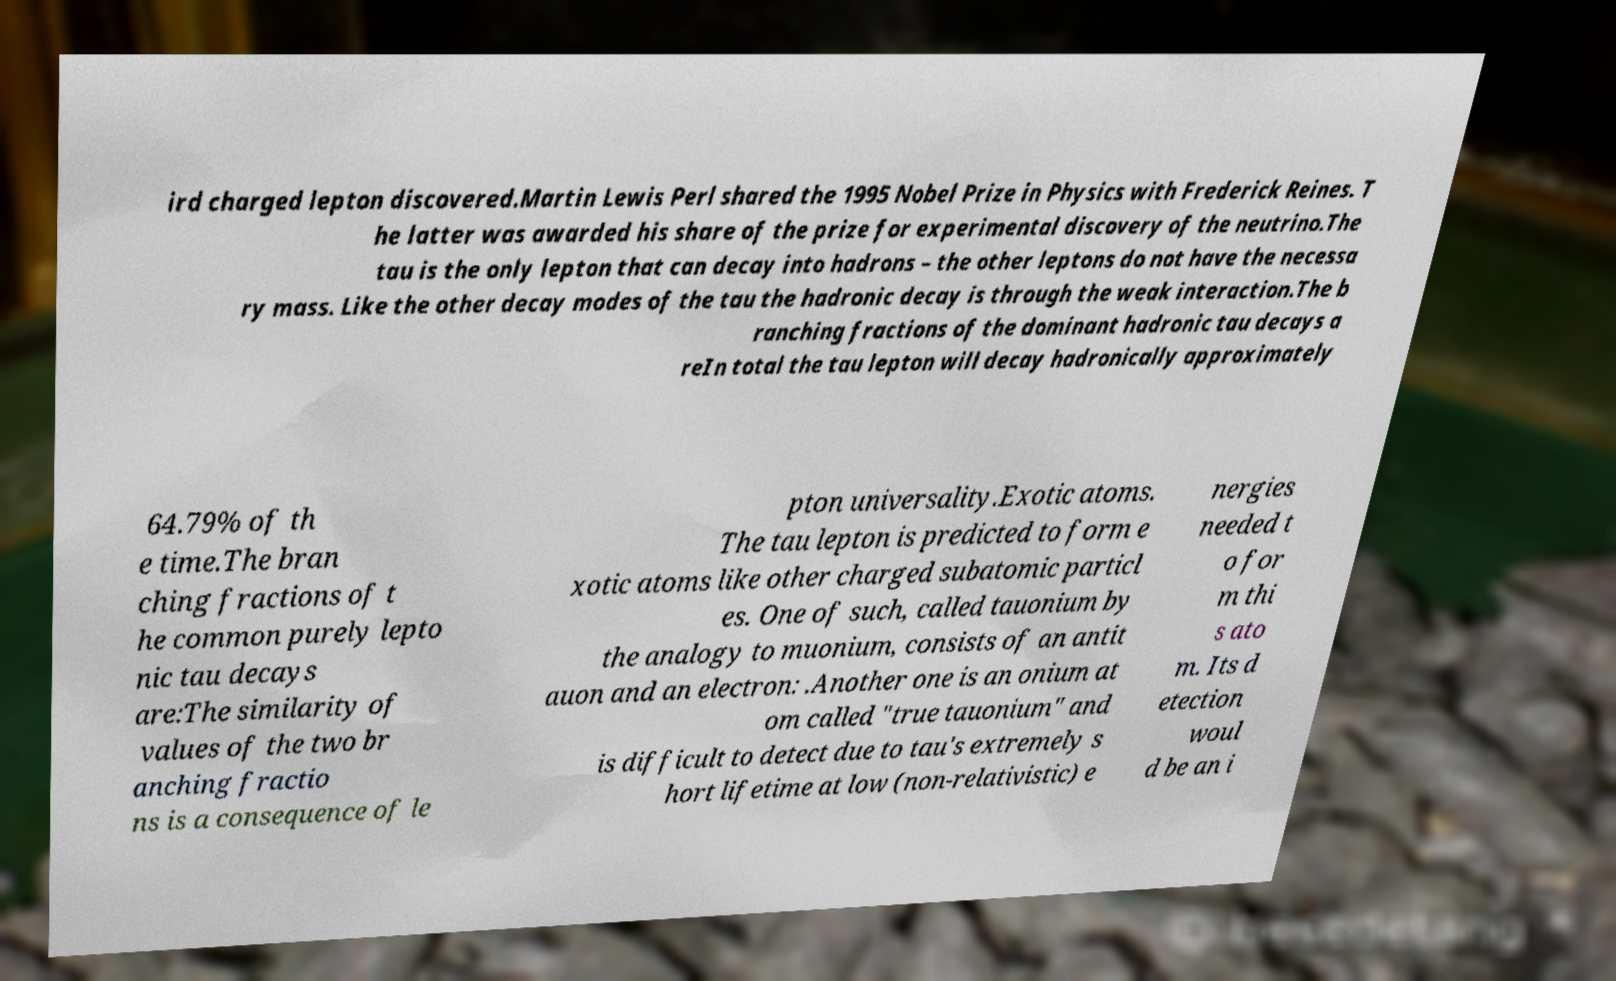What messages or text are displayed in this image? I need them in a readable, typed format. ird charged lepton discovered.Martin Lewis Perl shared the 1995 Nobel Prize in Physics with Frederick Reines. T he latter was awarded his share of the prize for experimental discovery of the neutrino.The tau is the only lepton that can decay into hadrons – the other leptons do not have the necessa ry mass. Like the other decay modes of the tau the hadronic decay is through the weak interaction.The b ranching fractions of the dominant hadronic tau decays a reIn total the tau lepton will decay hadronically approximately 64.79% of th e time.The bran ching fractions of t he common purely lepto nic tau decays are:The similarity of values of the two br anching fractio ns is a consequence of le pton universality.Exotic atoms. The tau lepton is predicted to form e xotic atoms like other charged subatomic particl es. One of such, called tauonium by the analogy to muonium, consists of an antit auon and an electron: .Another one is an onium at om called "true tauonium" and is difficult to detect due to tau's extremely s hort lifetime at low (non-relativistic) e nergies needed t o for m thi s ato m. Its d etection woul d be an i 